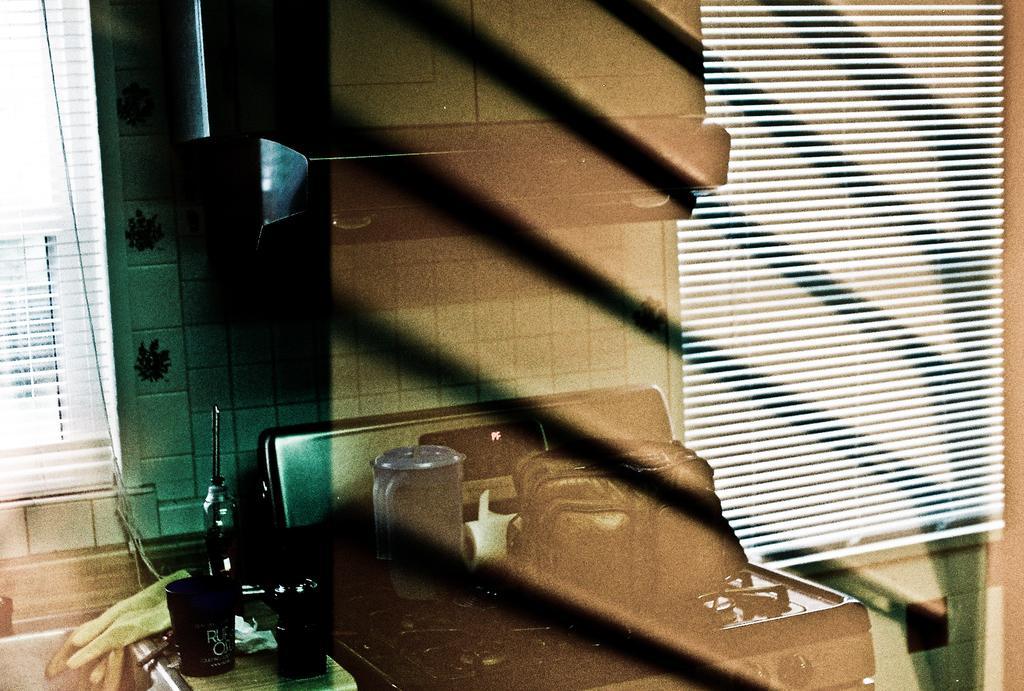Please provide a concise description of this image. In this image in the center it looks like a stove, and on the table there are some bags, juicer, cups, gloves and some other objects. In the background there is wall, window and blinds. 